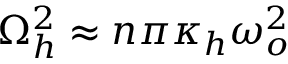Convert formula to latex. <formula><loc_0><loc_0><loc_500><loc_500>\Omega _ { h } ^ { 2 } \approx n \pi \kappa _ { h } \omega _ { o } ^ { 2 }</formula> 